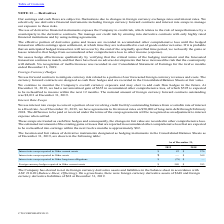From Cts Corporation's financial document, Which years does the table provide information for the location and fair values of derivative instruments designated as hedging instruments? The document shows two values: 2019 and 2018. From the document: "2019 2018 2019 2018..." Also, What were the Interest rate swaps reported in Other assets in 2018? According to the financial document, 369 (in thousands). The relevant text states: "nterest rate swaps reported in Other assets $ — $ 369..." Also, What was the Foreign currency hedges reported in Other current assets in 2019? According to the financial document, 580 (in thousands). The relevant text states: "urrency hedges reported in Other current assets $ 580 $ 393..." Also, How many years did Foreign currency hedges reported in Other current assets exceed $500 thousand? Based on the analysis, there are 1 instances (in thousands). The counting process: 2019. Also, can you calculate: What was the change in the Interest rate swaps reported in Other current assets between 2018 and 2019? Based on the calculation: 82-576, the result is -494 (in thousands). This is based on the information: "ate swaps reported in Other current assets $ 82 $ 576 s within the next twelve months is approximately $82...." The key data points involved are: 576, 82. Also, can you calculate: What was the percentage change in Foreign currency hedges reported in Other current assets between 2018 and 2019? To answer this question, I need to perform calculations using the financial data. The calculation is: (580-393)/393, which equals 47.58 (percentage). This is based on the information: "urrency hedges reported in Other current assets $ 580 $ 393 y hedges reported in Other current assets $ 580 $ 393..." The key data points involved are: 393, 580. 